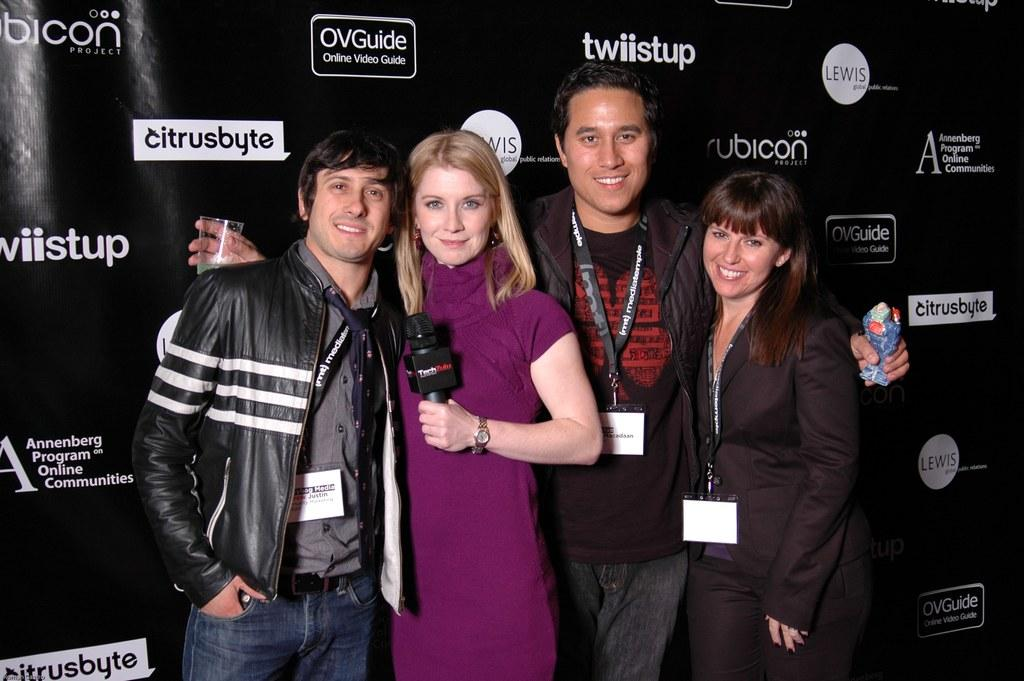<image>
Share a concise interpretation of the image provided. People posing in front of a OVGuide sign on the wall 